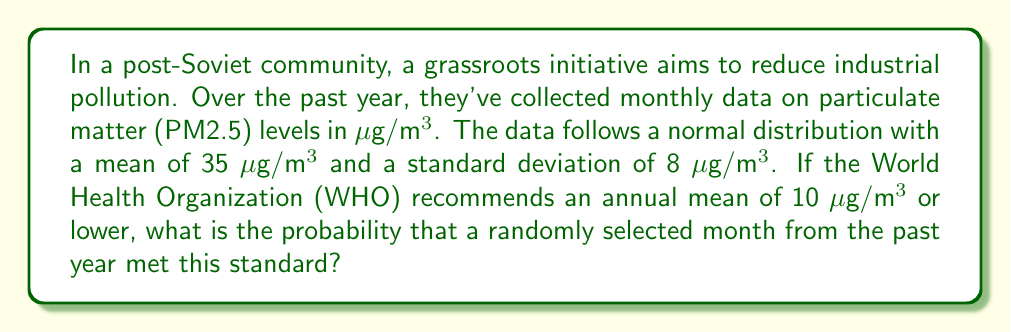Can you answer this question? To solve this problem, we need to use the properties of the normal distribution and the concept of z-scores.

1. First, we identify the given information:
   - The data follows a normal distribution
   - Mean (μ) = 35 μg/m³
   - Standard deviation (σ) = 8 μg/m³
   - WHO recommendation (target value) = 10 μg/m³

2. We need to find the probability that a randomly selected month had a PM2.5 level of 10 μg/m³ or lower.

3. To do this, we calculate the z-score for the target value:

   $$ z = \frac{x - \mu}{\sigma} $$

   Where:
   x = target value (10 μg/m³)
   μ = mean (35 μg/m³)
   σ = standard deviation (8 μg/m³)

   $$ z = \frac{10 - 35}{8} = -3.125 $$

4. The z-score of -3.125 represents the number of standard deviations the target value is below the mean.

5. To find the probability, we need to use a standard normal distribution table or a calculator with a built-in function for normal distribution probabilities.

6. The probability we're looking for is the area under the normal curve to the left of z = -3.125.

7. Using a calculator or standard normal distribution table, we find:

   $$ P(Z \leq -3.125) \approx 0.0009 $$

8. Convert this probability to a percentage:

   $$ 0.0009 \times 100\% = 0.09\% $$
Answer: The probability that a randomly selected month from the past year met the WHO standard (10 μg/m³ or lower) is approximately 0.09% or 0.0009. 